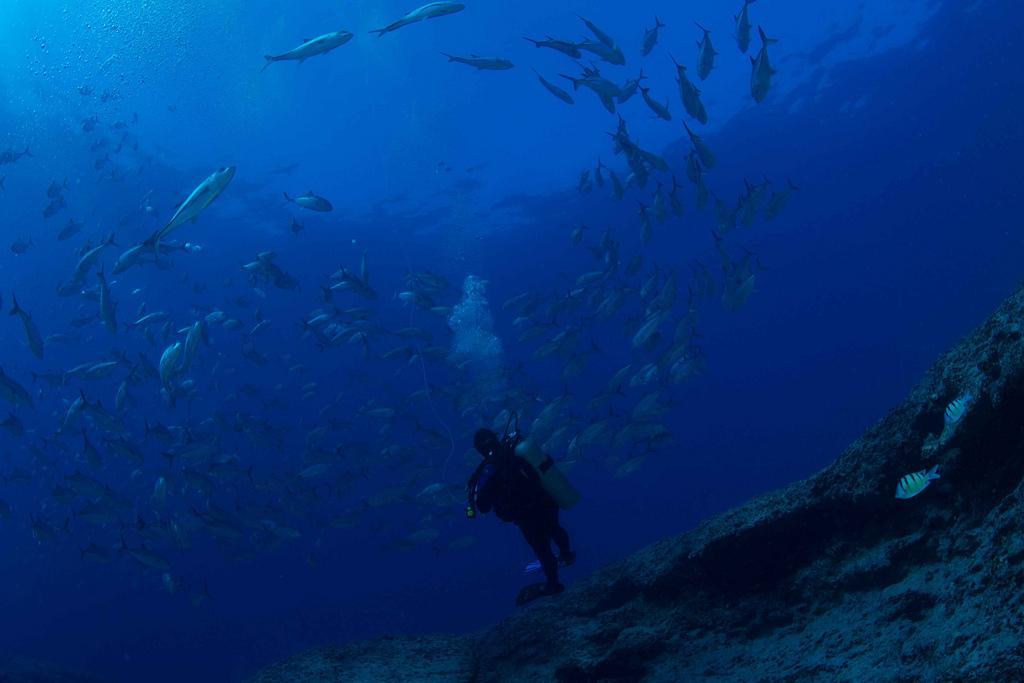In one or two sentences, can you explain what this image depicts? In this image we can see there is a man swimming in the water and carrying oxygen cylinder at the back, there are many fishes in the water. 